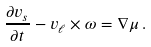<formula> <loc_0><loc_0><loc_500><loc_500>\frac { \partial v _ { s } } { \partial { t } } - v _ { \ell } \times \omega = \nabla \mu \, .</formula> 